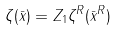<formula> <loc_0><loc_0><loc_500><loc_500>\zeta ( \bar { x } ) = Z _ { 1 } \zeta ^ { R } ( \bar { x } ^ { R } )</formula> 